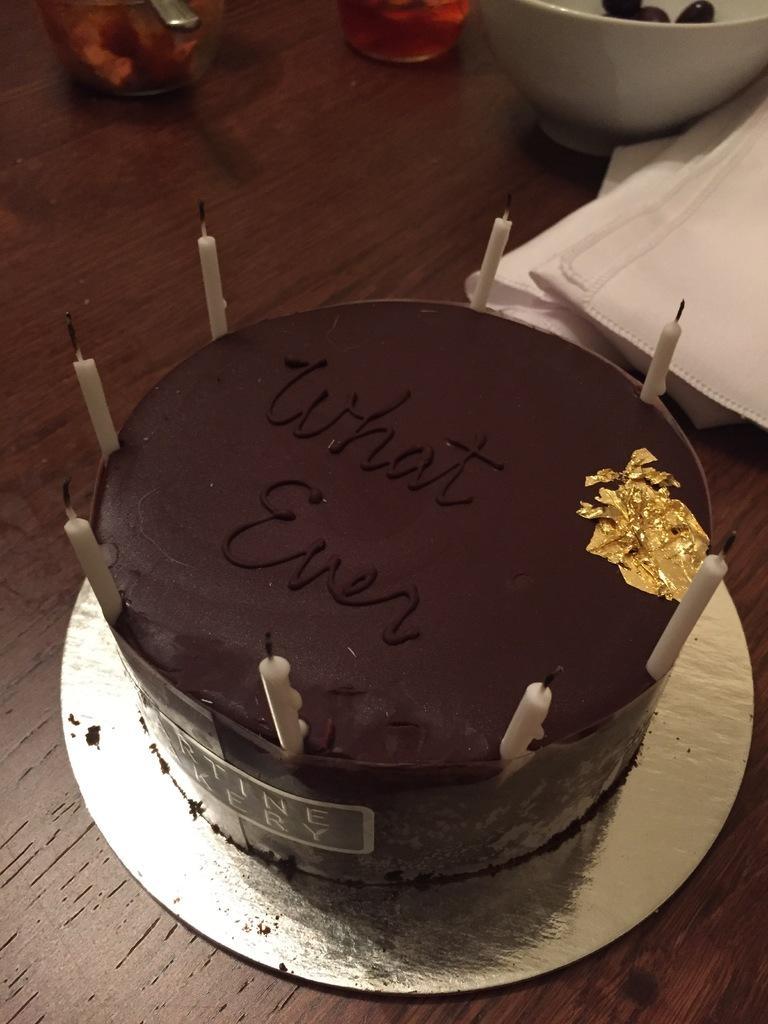Please provide a concise description of this image. In this Image I see a cake on which there are candles and it is written "What Even" on the cake, I can also see a bowl and few tissues over here 